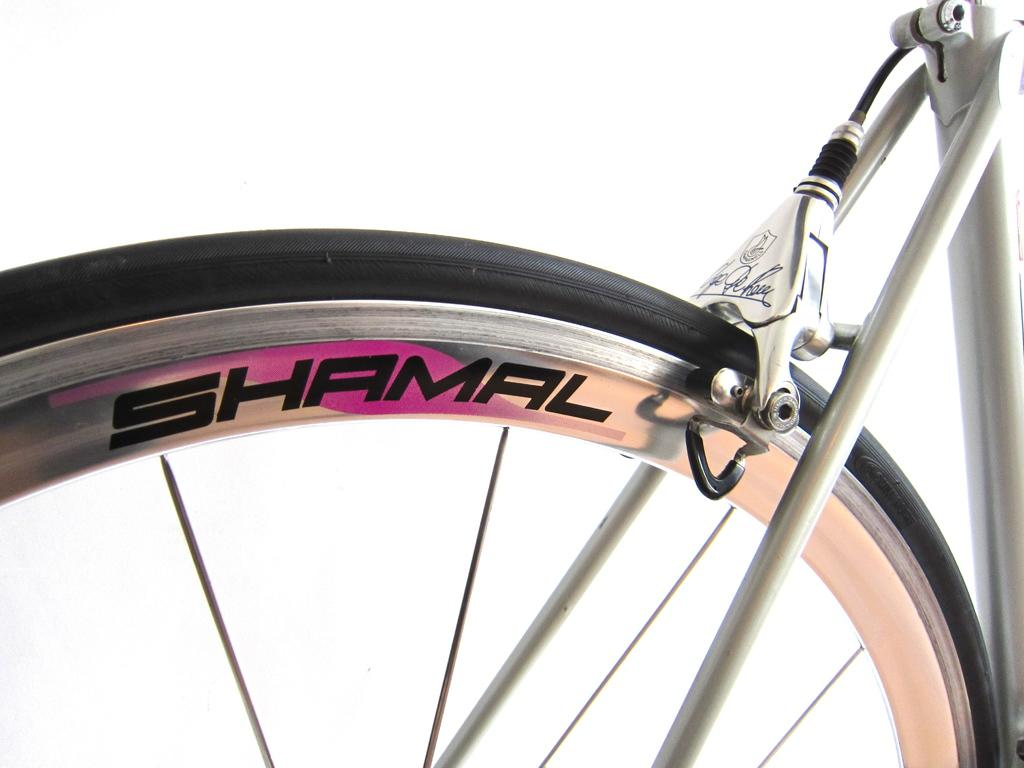What object is the main focus of the image? The main focus of the image is a wheel of a bicycle. What specific feature can be observed on the wheel? The wheel has spokes. What color is the background of the image? The background of the image is white. What type of cloth is draped over the bicycle in the image? There is no cloth draped over the bicycle in the image; it only shows the wheel with spokes against a white background. 